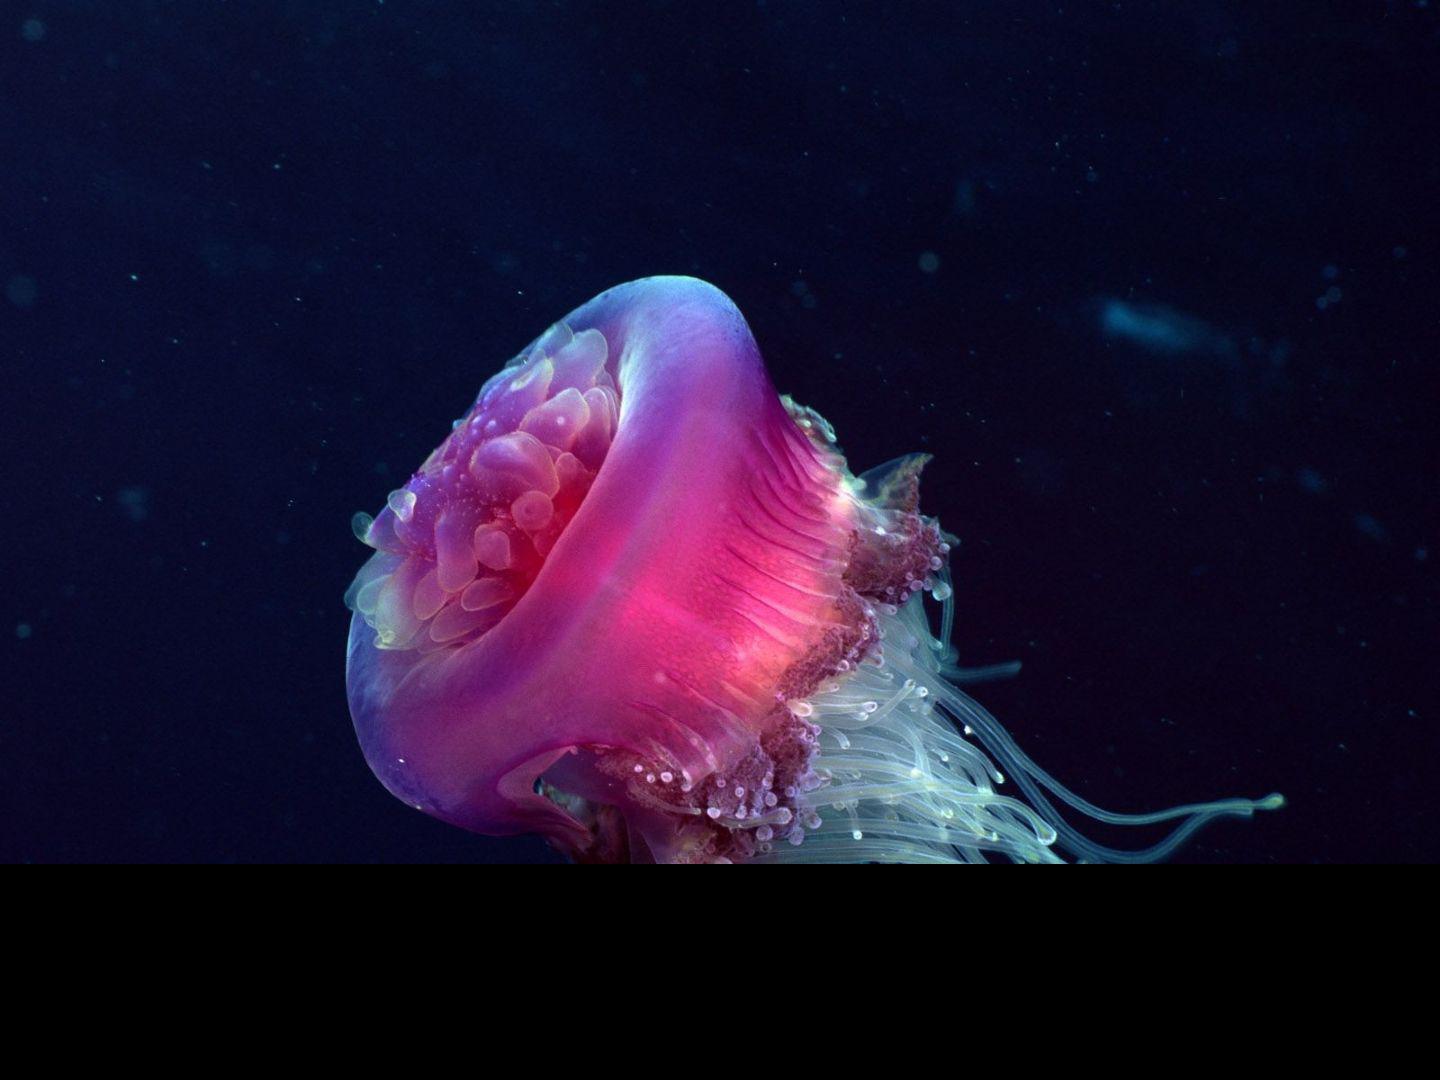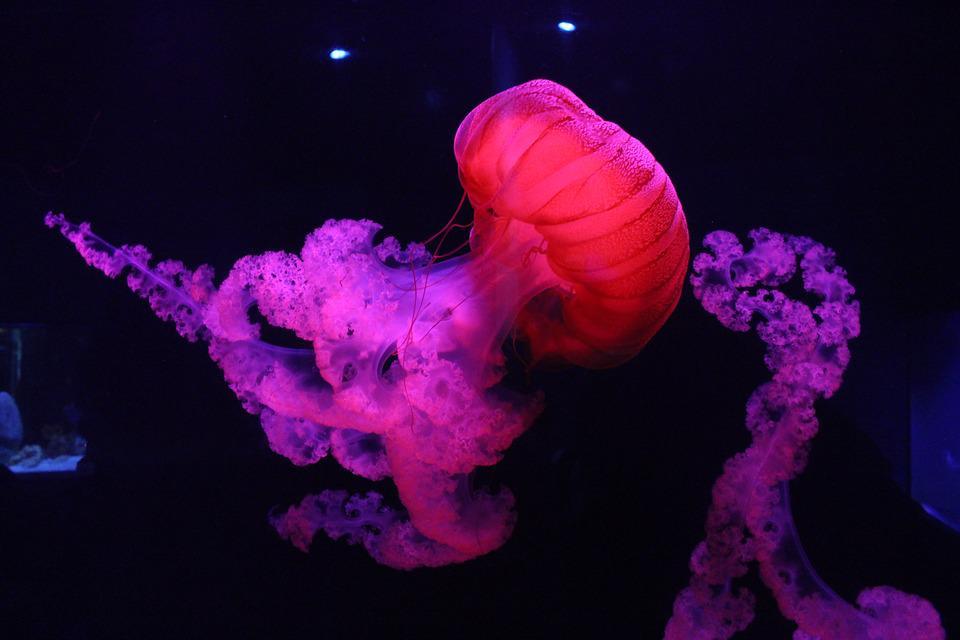The first image is the image on the left, the second image is the image on the right. Examine the images to the left and right. Is the description "An image shows a single jellyfish trailing something frilly and foamy looking." accurate? Answer yes or no. Yes. The first image is the image on the left, the second image is the image on the right. For the images shown, is this caption "At least one of the jellyfish is purplish pink in color." true? Answer yes or no. Yes. 